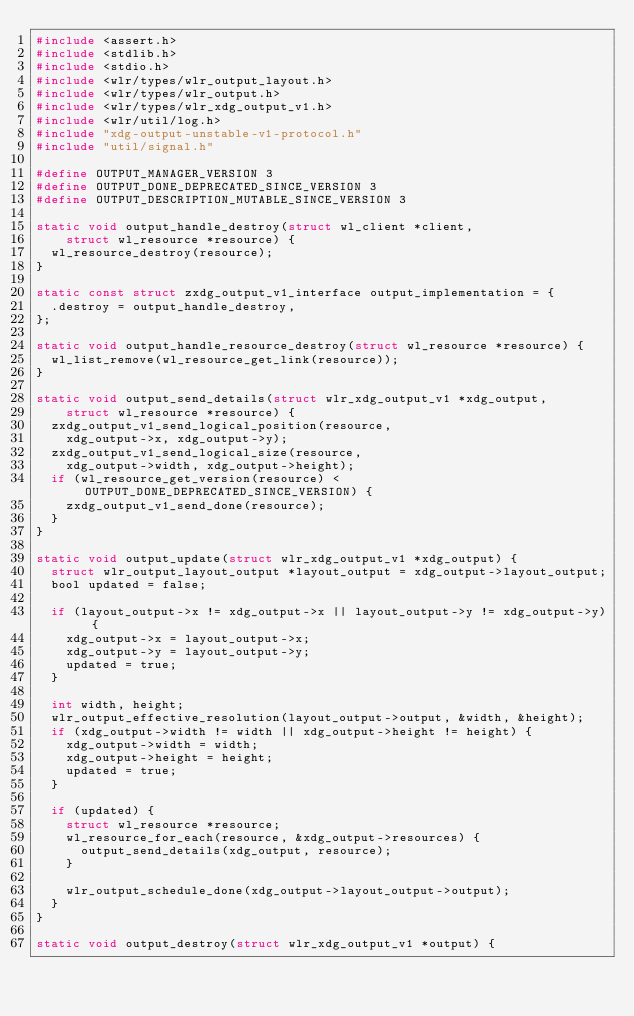Convert code to text. <code><loc_0><loc_0><loc_500><loc_500><_C_>#include <assert.h>
#include <stdlib.h>
#include <stdio.h>
#include <wlr/types/wlr_output_layout.h>
#include <wlr/types/wlr_output.h>
#include <wlr/types/wlr_xdg_output_v1.h>
#include <wlr/util/log.h>
#include "xdg-output-unstable-v1-protocol.h"
#include "util/signal.h"

#define OUTPUT_MANAGER_VERSION 3
#define OUTPUT_DONE_DEPRECATED_SINCE_VERSION 3
#define OUTPUT_DESCRIPTION_MUTABLE_SINCE_VERSION 3

static void output_handle_destroy(struct wl_client *client,
		struct wl_resource *resource) {
	wl_resource_destroy(resource);
}

static const struct zxdg_output_v1_interface output_implementation = {
	.destroy = output_handle_destroy,
};

static void output_handle_resource_destroy(struct wl_resource *resource) {
	wl_list_remove(wl_resource_get_link(resource));
}

static void output_send_details(struct wlr_xdg_output_v1 *xdg_output,
		struct wl_resource *resource) {
	zxdg_output_v1_send_logical_position(resource,
		xdg_output->x, xdg_output->y);
	zxdg_output_v1_send_logical_size(resource,
		xdg_output->width, xdg_output->height);
	if (wl_resource_get_version(resource) < OUTPUT_DONE_DEPRECATED_SINCE_VERSION) {
		zxdg_output_v1_send_done(resource);
	}
}

static void output_update(struct wlr_xdg_output_v1 *xdg_output) {
	struct wlr_output_layout_output *layout_output = xdg_output->layout_output;
	bool updated = false;

	if (layout_output->x != xdg_output->x || layout_output->y != xdg_output->y) {
		xdg_output->x = layout_output->x;
		xdg_output->y = layout_output->y;
		updated = true;
	}

	int width, height;
	wlr_output_effective_resolution(layout_output->output, &width, &height);
	if (xdg_output->width != width || xdg_output->height != height) {
		xdg_output->width = width;
		xdg_output->height = height;
		updated = true;
	}

	if (updated) {
		struct wl_resource *resource;
		wl_resource_for_each(resource, &xdg_output->resources) {
			output_send_details(xdg_output, resource);
		}

		wlr_output_schedule_done(xdg_output->layout_output->output);
	}
}

static void output_destroy(struct wlr_xdg_output_v1 *output) {</code> 